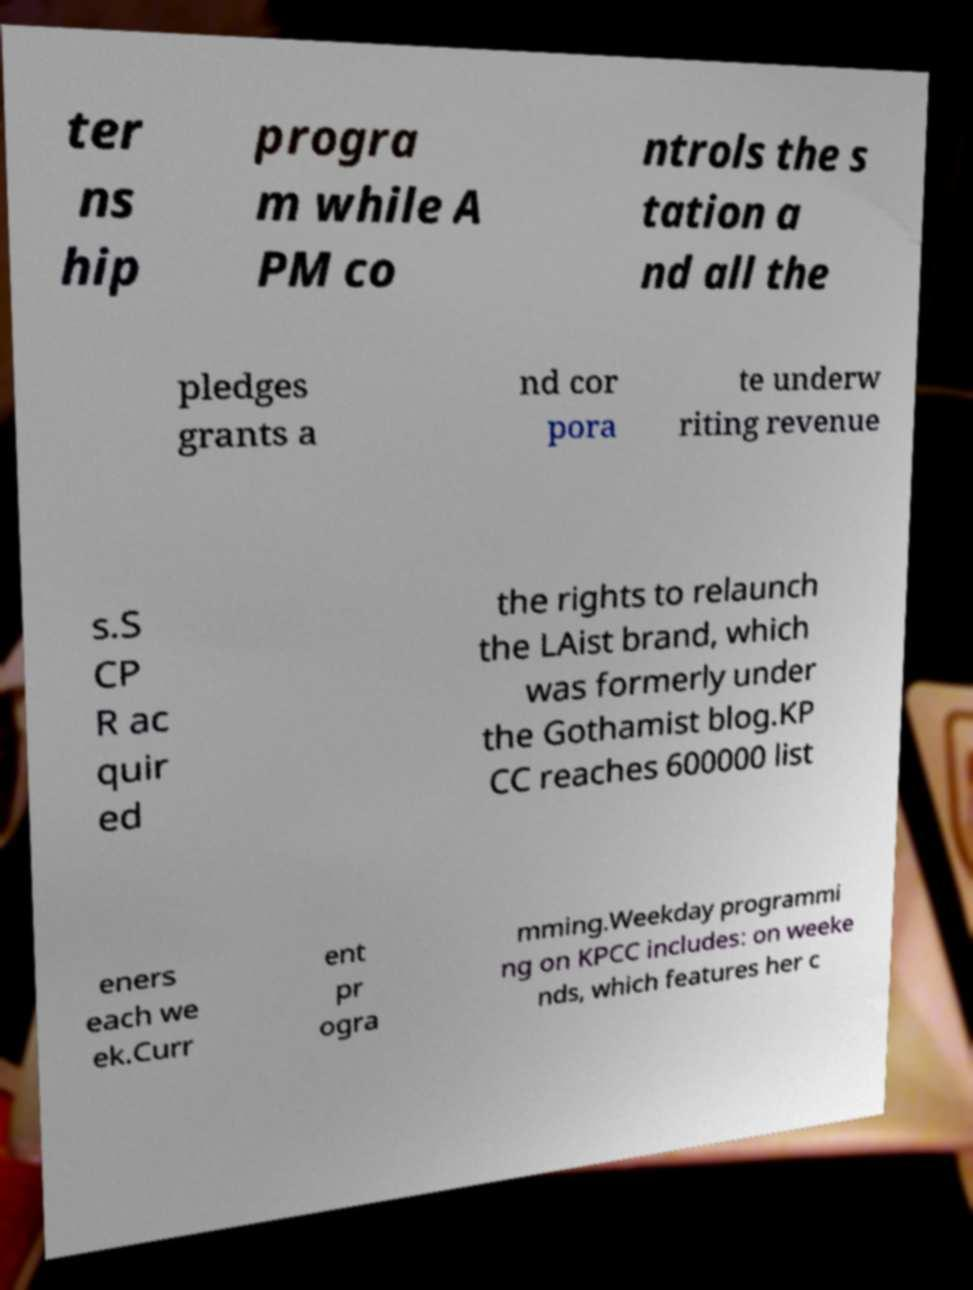What messages or text are displayed in this image? I need them in a readable, typed format. ter ns hip progra m while A PM co ntrols the s tation a nd all the pledges grants a nd cor pora te underw riting revenue s.S CP R ac quir ed the rights to relaunch the LAist brand, which was formerly under the Gothamist blog.KP CC reaches 600000 list eners each we ek.Curr ent pr ogra mming.Weekday programmi ng on KPCC includes: on weeke nds, which features her c 